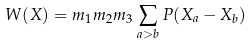<formula> <loc_0><loc_0><loc_500><loc_500>W ( X ) = m _ { 1 } m _ { 2 } m _ { 3 } \sum _ { a > b } P ( X _ { a } - X _ { b } )</formula> 